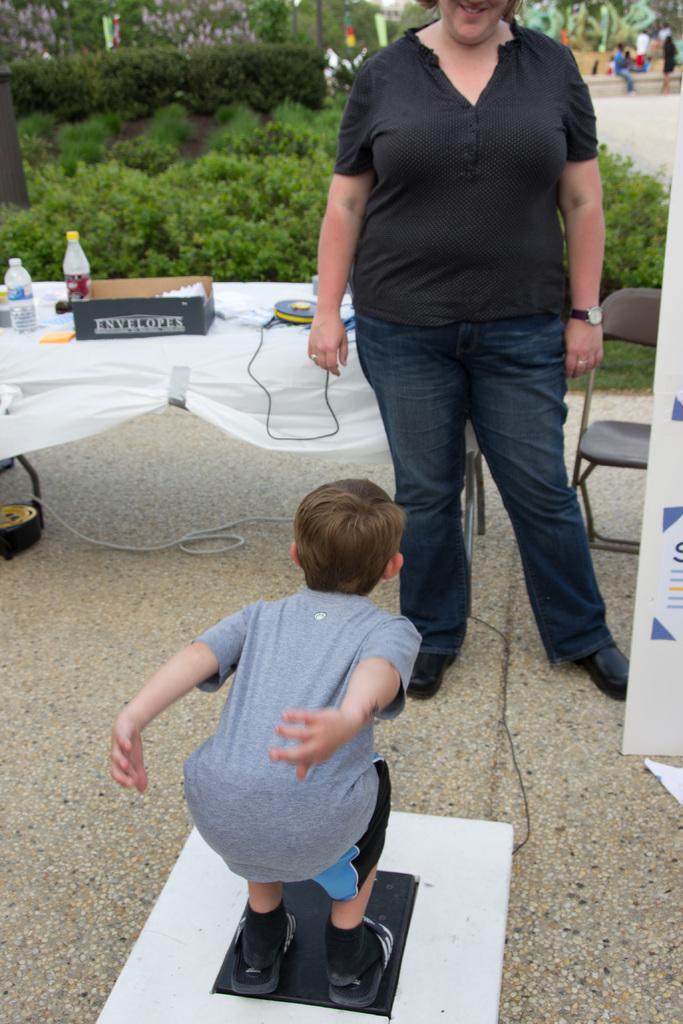Please provide a concise description of this image. In this picture I can see a boy standing on an object, there is a woman standing, there are bottles, box and some other objects on the table, there is a chair, it looks like a board, there are plants, trees and there are group of people. 